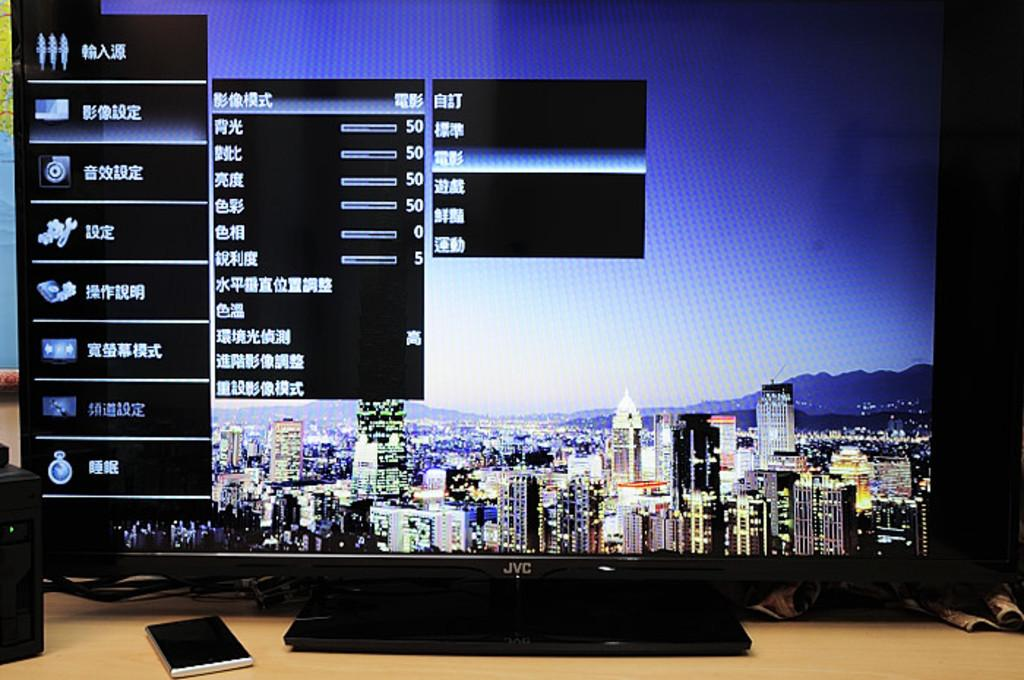What electronic device is on the table in the image? There is a monitor on the table in the image. What else can be seen on the table besides the monitor? There is a book and unspecified "things" on the table. What is displayed on the monitor's screen? The monitor is displaying a screen with buildings visible. What type of yarn is being used to create the buildings on the monitor's screen? There is no yarn present in the image, as the buildings are displayed on the monitor's screen. What reward is being given to the person who created the buildings on the monitor's screen? There is no indication in the image that a reward is being given for creating the buildings on the monitor's screen. --- Facts: 1. There is a person standing near a tree. 2. The person is holding a camera. 3. The tree has green leaves. 4. The sky is visible in the background. Absurd Topics: parrot, bicycle, ocean Conversation: What is the person in the image doing? The person is standing near a tree. What object is the person holding? The person is holding a camera. What is the color of the tree's leaves? The tree has green leaves. What can be seen in the background of the image? The sky is visible in the background. Reasoning: Let's think step by step in order to produce the conversation. We start by identifying the main subject in the image, which is the person standing near a tree. Then, we expand the conversation to include other items that are also visible, such as the camera the person is holding and the color of the tree's leaves. Finally, we describe the background of the image, which is the sky. Absurd Question/Answer: Can you tell me how many parrots are sitting on the branches of the tree in the image? There are no parrots visible on the tree in the image. Is the person riding a bicycle while holding the camera in the image? There is no bicycle present in the image. --- Facts: 1. There is a person sitting on a bench. 2. The person is reading a book. 3. There is a water fountain in the background. 4. The sky is visible in the background. Absurd Topics: elephant, sandcastle, volcano Conversation: What is the person in the image doing? The person is sitting on a bench. What activity is the person engaged in while sitting on the bench? The person is reading a book. What can be seen in the background of the image? There is a water fountain and the sky visible in the background. Reasoning: Let's think step by step in order to produce the conversation. We start by identifying 